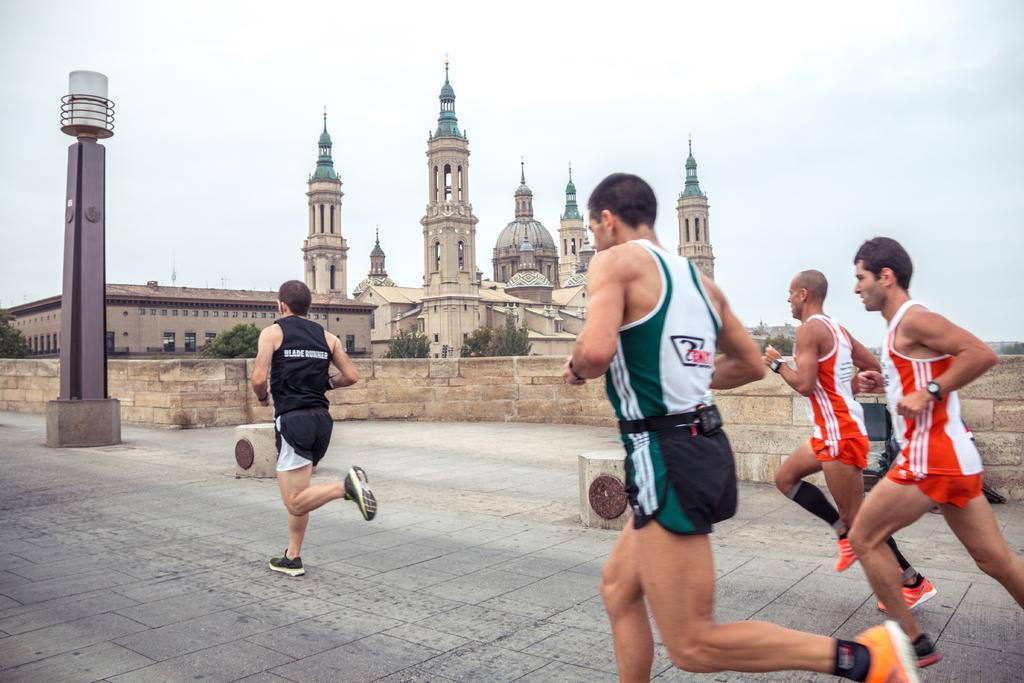What are the persons in the image doing? The persons in the image are running. On what surface are the persons running? The persons are running on the ground. What can be seen in the background of the image? There is a building, trees, and the sky visible in the background of the image. What type of ball is being used to reduce friction on the table in the image? There is no ball or table present in the image; it features persons running on the ground with a background of a building, trees, and the sky. 